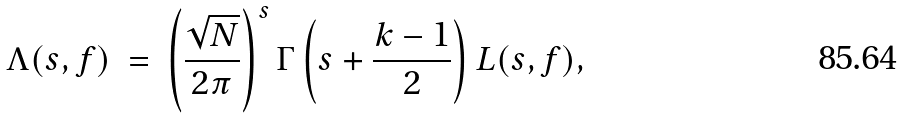<formula> <loc_0><loc_0><loc_500><loc_500>\Lambda ( s , f ) \ = \ \left ( \frac { \sqrt { N } } { 2 \pi } \right ) ^ { s } \Gamma \left ( s + \frac { k - 1 } { 2 } \right ) L ( s , f ) ,</formula> 